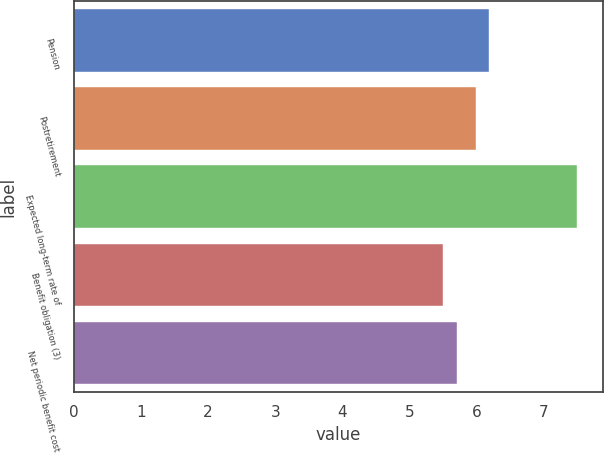Convert chart. <chart><loc_0><loc_0><loc_500><loc_500><bar_chart><fcel>Pension<fcel>Postretirement<fcel>Expected long-term rate of<fcel>Benefit obligation (3)<fcel>Net periodic benefit cost<nl><fcel>6.19<fcel>5.99<fcel>7.5<fcel>5.5<fcel>5.7<nl></chart> 